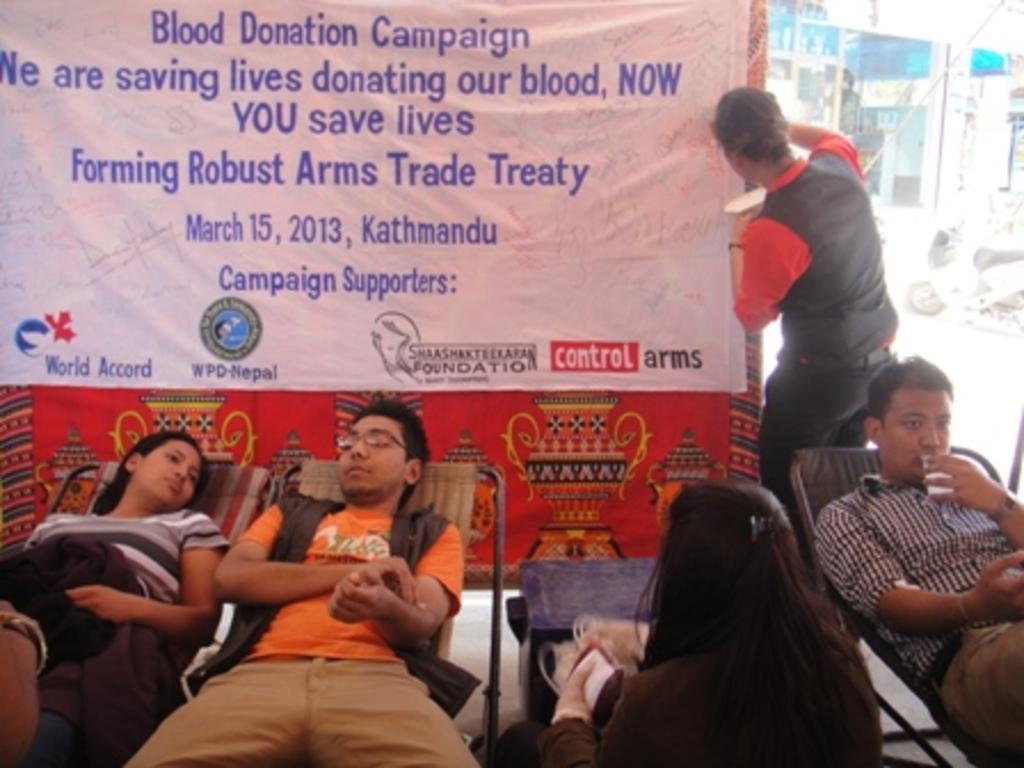Can you describe this image briefly? I can see in this image a banner and a group of people among them few are sitting on a chair and a person in the background is standing on the ground. In the background I can see there is a vehicle and buildings. 